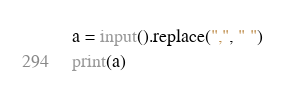Convert code to text. <code><loc_0><loc_0><loc_500><loc_500><_Python_>a = input().replace(",", " ")
print(a)</code> 